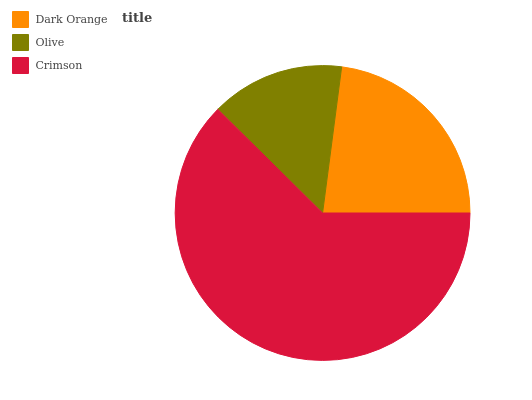Is Olive the minimum?
Answer yes or no. Yes. Is Crimson the maximum?
Answer yes or no. Yes. Is Crimson the minimum?
Answer yes or no. No. Is Olive the maximum?
Answer yes or no. No. Is Crimson greater than Olive?
Answer yes or no. Yes. Is Olive less than Crimson?
Answer yes or no. Yes. Is Olive greater than Crimson?
Answer yes or no. No. Is Crimson less than Olive?
Answer yes or no. No. Is Dark Orange the high median?
Answer yes or no. Yes. Is Dark Orange the low median?
Answer yes or no. Yes. Is Olive the high median?
Answer yes or no. No. Is Crimson the low median?
Answer yes or no. No. 